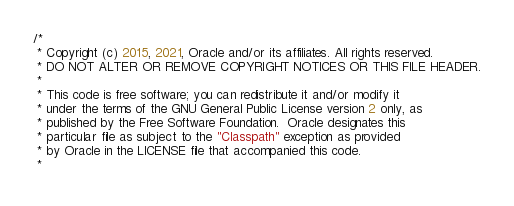Convert code to text. <code><loc_0><loc_0><loc_500><loc_500><_Java_>/*
 * Copyright (c) 2015, 2021, Oracle and/or its affiliates. All rights reserved.
 * DO NOT ALTER OR REMOVE COPYRIGHT NOTICES OR THIS FILE HEADER.
 *
 * This code is free software; you can redistribute it and/or modify it
 * under the terms of the GNU General Public License version 2 only, as
 * published by the Free Software Foundation.  Oracle designates this
 * particular file as subject to the "Classpath" exception as provided
 * by Oracle in the LICENSE file that accompanied this code.
 *</code> 